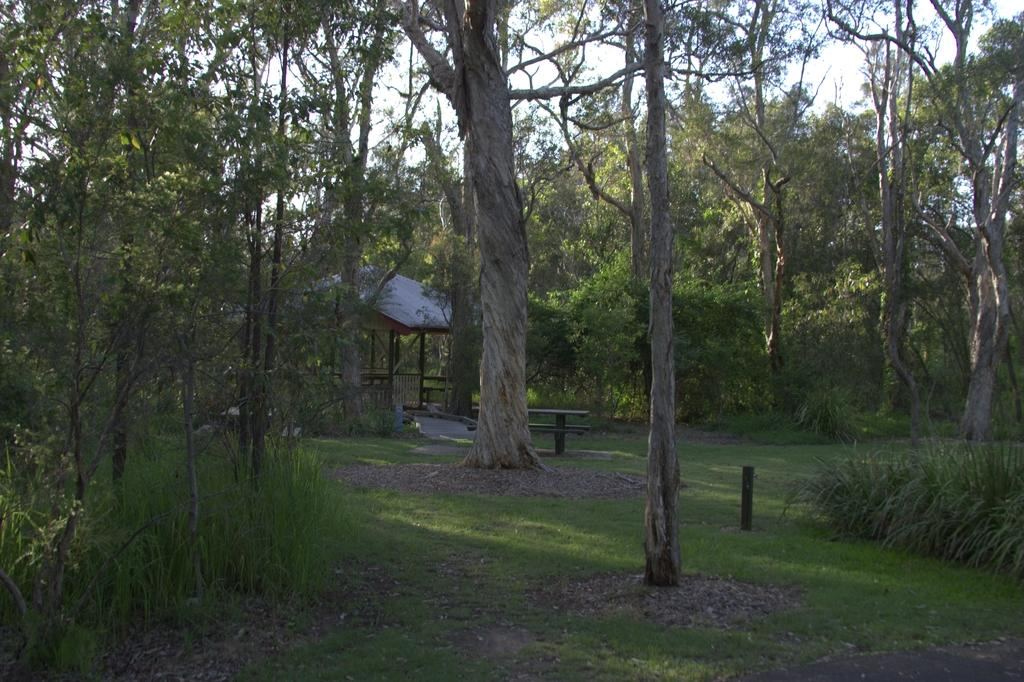What type of vegetation can be seen in the image? There are trees, plants, and grass in the image. What structure is present in the image? There is a shelter in the image. What can be seen in the background of the image? The sky is visible in the background of the image. What type of holiday is being celebrated in the image? There is no indication of a holiday being celebrated in the image. What experience can be gained from observing the rays in the image? There are no rays present in the image, so no experience can be gained from observing them. 